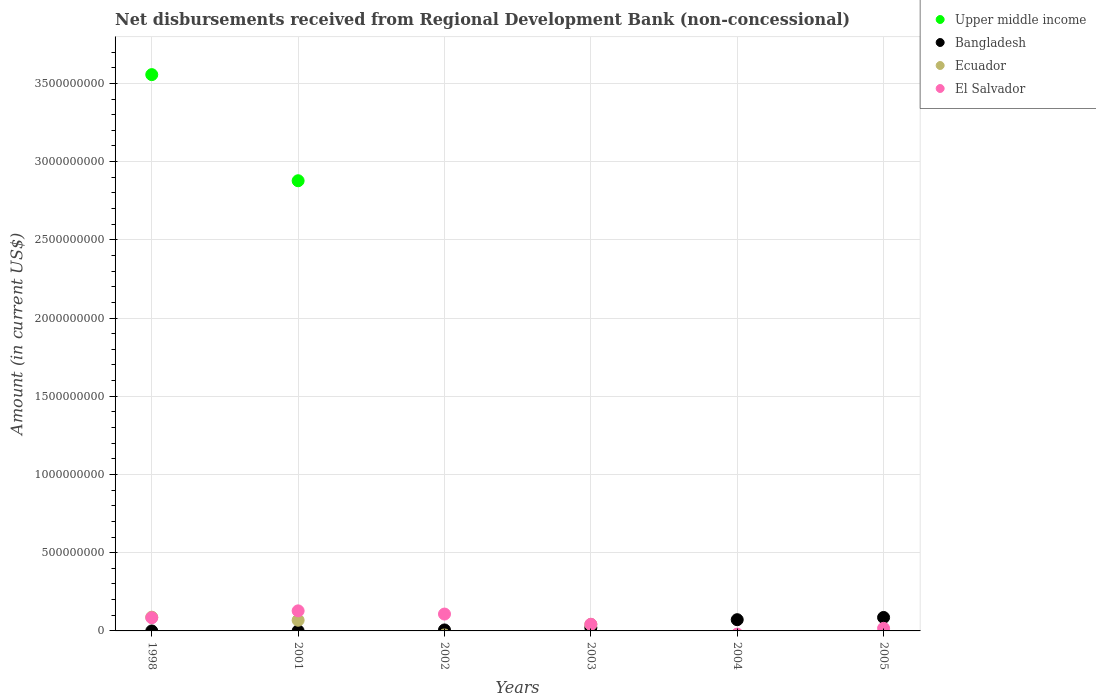What is the amount of disbursements received from Regional Development Bank in Upper middle income in 2001?
Your response must be concise. 2.88e+09. Across all years, what is the maximum amount of disbursements received from Regional Development Bank in El Salvador?
Provide a short and direct response. 1.28e+08. Across all years, what is the minimum amount of disbursements received from Regional Development Bank in El Salvador?
Make the answer very short. 0. In which year was the amount of disbursements received from Regional Development Bank in El Salvador maximum?
Provide a succinct answer. 2001. What is the total amount of disbursements received from Regional Development Bank in Ecuador in the graph?
Your response must be concise. 1.98e+08. What is the difference between the amount of disbursements received from Regional Development Bank in Bangladesh in 2002 and that in 2004?
Your answer should be compact. -6.55e+07. What is the difference between the amount of disbursements received from Regional Development Bank in Bangladesh in 2004 and the amount of disbursements received from Regional Development Bank in Ecuador in 2002?
Offer a terse response. 7.18e+07. What is the average amount of disbursements received from Regional Development Bank in Bangladesh per year?
Your answer should be very brief. 3.08e+07. In the year 2005, what is the difference between the amount of disbursements received from Regional Development Bank in Bangladesh and amount of disbursements received from Regional Development Bank in El Salvador?
Your response must be concise. 6.94e+07. What is the ratio of the amount of disbursements received from Regional Development Bank in El Salvador in 2003 to that in 2005?
Provide a succinct answer. 2.54. What is the difference between the highest and the second highest amount of disbursements received from Regional Development Bank in Bangladesh?
Make the answer very short. 1.43e+07. What is the difference between the highest and the lowest amount of disbursements received from Regional Development Bank in El Salvador?
Your answer should be compact. 1.28e+08. Does the amount of disbursements received from Regional Development Bank in Upper middle income monotonically increase over the years?
Offer a terse response. No. Is the amount of disbursements received from Regional Development Bank in El Salvador strictly less than the amount of disbursements received from Regional Development Bank in Bangladesh over the years?
Make the answer very short. No. How many years are there in the graph?
Keep it short and to the point. 6. What is the difference between two consecutive major ticks on the Y-axis?
Provide a short and direct response. 5.00e+08. Does the graph contain grids?
Provide a short and direct response. Yes. How are the legend labels stacked?
Your answer should be compact. Vertical. What is the title of the graph?
Offer a very short reply. Net disbursements received from Regional Development Bank (non-concessional). What is the label or title of the X-axis?
Offer a very short reply. Years. What is the label or title of the Y-axis?
Your answer should be compact. Amount (in current US$). What is the Amount (in current US$) in Upper middle income in 1998?
Your answer should be very brief. 3.56e+09. What is the Amount (in current US$) of Bangladesh in 1998?
Your answer should be compact. 0. What is the Amount (in current US$) of Ecuador in 1998?
Give a very brief answer. 8.79e+07. What is the Amount (in current US$) in El Salvador in 1998?
Offer a terse response. 8.43e+07. What is the Amount (in current US$) in Upper middle income in 2001?
Your answer should be compact. 2.88e+09. What is the Amount (in current US$) in Bangladesh in 2001?
Provide a succinct answer. 2.38e+05. What is the Amount (in current US$) of Ecuador in 2001?
Keep it short and to the point. 6.83e+07. What is the Amount (in current US$) in El Salvador in 2001?
Provide a short and direct response. 1.28e+08. What is the Amount (in current US$) in Upper middle income in 2002?
Provide a succinct answer. 0. What is the Amount (in current US$) of Bangladesh in 2002?
Give a very brief answer. 6.25e+06. What is the Amount (in current US$) of El Salvador in 2002?
Your response must be concise. 1.08e+08. What is the Amount (in current US$) in Bangladesh in 2003?
Offer a very short reply. 2.05e+07. What is the Amount (in current US$) of Ecuador in 2003?
Provide a short and direct response. 4.21e+07. What is the Amount (in current US$) in El Salvador in 2003?
Offer a very short reply. 4.24e+07. What is the Amount (in current US$) of Bangladesh in 2004?
Your answer should be very brief. 7.18e+07. What is the Amount (in current US$) of Ecuador in 2004?
Your answer should be very brief. 0. What is the Amount (in current US$) of El Salvador in 2004?
Make the answer very short. 0. What is the Amount (in current US$) of Bangladesh in 2005?
Offer a terse response. 8.61e+07. What is the Amount (in current US$) of El Salvador in 2005?
Ensure brevity in your answer.  1.67e+07. Across all years, what is the maximum Amount (in current US$) of Upper middle income?
Keep it short and to the point. 3.56e+09. Across all years, what is the maximum Amount (in current US$) of Bangladesh?
Your answer should be very brief. 8.61e+07. Across all years, what is the maximum Amount (in current US$) of Ecuador?
Keep it short and to the point. 8.79e+07. Across all years, what is the maximum Amount (in current US$) in El Salvador?
Your answer should be compact. 1.28e+08. Across all years, what is the minimum Amount (in current US$) of Upper middle income?
Make the answer very short. 0. Across all years, what is the minimum Amount (in current US$) in Bangladesh?
Keep it short and to the point. 0. Across all years, what is the minimum Amount (in current US$) of Ecuador?
Your answer should be very brief. 0. What is the total Amount (in current US$) of Upper middle income in the graph?
Your response must be concise. 6.43e+09. What is the total Amount (in current US$) in Bangladesh in the graph?
Provide a short and direct response. 1.85e+08. What is the total Amount (in current US$) in Ecuador in the graph?
Keep it short and to the point. 1.98e+08. What is the total Amount (in current US$) of El Salvador in the graph?
Offer a very short reply. 3.79e+08. What is the difference between the Amount (in current US$) of Upper middle income in 1998 and that in 2001?
Your response must be concise. 6.78e+08. What is the difference between the Amount (in current US$) of Ecuador in 1998 and that in 2001?
Provide a short and direct response. 1.96e+07. What is the difference between the Amount (in current US$) in El Salvador in 1998 and that in 2001?
Give a very brief answer. -4.39e+07. What is the difference between the Amount (in current US$) in El Salvador in 1998 and that in 2002?
Offer a terse response. -2.35e+07. What is the difference between the Amount (in current US$) in Ecuador in 1998 and that in 2003?
Your response must be concise. 4.58e+07. What is the difference between the Amount (in current US$) in El Salvador in 1998 and that in 2003?
Your answer should be very brief. 4.20e+07. What is the difference between the Amount (in current US$) in El Salvador in 1998 and that in 2005?
Offer a very short reply. 6.77e+07. What is the difference between the Amount (in current US$) in Bangladesh in 2001 and that in 2002?
Ensure brevity in your answer.  -6.01e+06. What is the difference between the Amount (in current US$) of El Salvador in 2001 and that in 2002?
Provide a succinct answer. 2.04e+07. What is the difference between the Amount (in current US$) of Bangladesh in 2001 and that in 2003?
Provide a succinct answer. -2.03e+07. What is the difference between the Amount (in current US$) of Ecuador in 2001 and that in 2003?
Your response must be concise. 2.61e+07. What is the difference between the Amount (in current US$) of El Salvador in 2001 and that in 2003?
Make the answer very short. 8.59e+07. What is the difference between the Amount (in current US$) in Bangladesh in 2001 and that in 2004?
Your answer should be very brief. -7.15e+07. What is the difference between the Amount (in current US$) in Bangladesh in 2001 and that in 2005?
Your answer should be compact. -8.58e+07. What is the difference between the Amount (in current US$) in El Salvador in 2001 and that in 2005?
Your answer should be very brief. 1.12e+08. What is the difference between the Amount (in current US$) of Bangladesh in 2002 and that in 2003?
Keep it short and to the point. -1.43e+07. What is the difference between the Amount (in current US$) in El Salvador in 2002 and that in 2003?
Give a very brief answer. 6.55e+07. What is the difference between the Amount (in current US$) in Bangladesh in 2002 and that in 2004?
Ensure brevity in your answer.  -6.55e+07. What is the difference between the Amount (in current US$) in Bangladesh in 2002 and that in 2005?
Give a very brief answer. -7.98e+07. What is the difference between the Amount (in current US$) in El Salvador in 2002 and that in 2005?
Offer a very short reply. 9.12e+07. What is the difference between the Amount (in current US$) of Bangladesh in 2003 and that in 2004?
Keep it short and to the point. -5.13e+07. What is the difference between the Amount (in current US$) of Bangladesh in 2003 and that in 2005?
Keep it short and to the point. -6.56e+07. What is the difference between the Amount (in current US$) in El Salvador in 2003 and that in 2005?
Ensure brevity in your answer.  2.57e+07. What is the difference between the Amount (in current US$) in Bangladesh in 2004 and that in 2005?
Ensure brevity in your answer.  -1.43e+07. What is the difference between the Amount (in current US$) in Upper middle income in 1998 and the Amount (in current US$) in Bangladesh in 2001?
Give a very brief answer. 3.56e+09. What is the difference between the Amount (in current US$) in Upper middle income in 1998 and the Amount (in current US$) in Ecuador in 2001?
Your answer should be compact. 3.49e+09. What is the difference between the Amount (in current US$) in Upper middle income in 1998 and the Amount (in current US$) in El Salvador in 2001?
Provide a short and direct response. 3.43e+09. What is the difference between the Amount (in current US$) of Ecuador in 1998 and the Amount (in current US$) of El Salvador in 2001?
Your answer should be compact. -4.03e+07. What is the difference between the Amount (in current US$) of Upper middle income in 1998 and the Amount (in current US$) of Bangladesh in 2002?
Offer a very short reply. 3.55e+09. What is the difference between the Amount (in current US$) of Upper middle income in 1998 and the Amount (in current US$) of El Salvador in 2002?
Offer a very short reply. 3.45e+09. What is the difference between the Amount (in current US$) in Ecuador in 1998 and the Amount (in current US$) in El Salvador in 2002?
Provide a short and direct response. -2.00e+07. What is the difference between the Amount (in current US$) in Upper middle income in 1998 and the Amount (in current US$) in Bangladesh in 2003?
Your answer should be compact. 3.54e+09. What is the difference between the Amount (in current US$) in Upper middle income in 1998 and the Amount (in current US$) in Ecuador in 2003?
Your answer should be compact. 3.51e+09. What is the difference between the Amount (in current US$) in Upper middle income in 1998 and the Amount (in current US$) in El Salvador in 2003?
Keep it short and to the point. 3.51e+09. What is the difference between the Amount (in current US$) in Ecuador in 1998 and the Amount (in current US$) in El Salvador in 2003?
Your answer should be compact. 4.55e+07. What is the difference between the Amount (in current US$) of Upper middle income in 1998 and the Amount (in current US$) of Bangladesh in 2004?
Your response must be concise. 3.48e+09. What is the difference between the Amount (in current US$) of Upper middle income in 1998 and the Amount (in current US$) of Bangladesh in 2005?
Ensure brevity in your answer.  3.47e+09. What is the difference between the Amount (in current US$) of Upper middle income in 1998 and the Amount (in current US$) of El Salvador in 2005?
Your answer should be very brief. 3.54e+09. What is the difference between the Amount (in current US$) in Ecuador in 1998 and the Amount (in current US$) in El Salvador in 2005?
Your response must be concise. 7.12e+07. What is the difference between the Amount (in current US$) of Upper middle income in 2001 and the Amount (in current US$) of Bangladesh in 2002?
Give a very brief answer. 2.87e+09. What is the difference between the Amount (in current US$) in Upper middle income in 2001 and the Amount (in current US$) in El Salvador in 2002?
Give a very brief answer. 2.77e+09. What is the difference between the Amount (in current US$) of Bangladesh in 2001 and the Amount (in current US$) of El Salvador in 2002?
Your answer should be compact. -1.08e+08. What is the difference between the Amount (in current US$) in Ecuador in 2001 and the Amount (in current US$) in El Salvador in 2002?
Offer a very short reply. -3.96e+07. What is the difference between the Amount (in current US$) in Upper middle income in 2001 and the Amount (in current US$) in Bangladesh in 2003?
Provide a succinct answer. 2.86e+09. What is the difference between the Amount (in current US$) in Upper middle income in 2001 and the Amount (in current US$) in Ecuador in 2003?
Provide a short and direct response. 2.84e+09. What is the difference between the Amount (in current US$) of Upper middle income in 2001 and the Amount (in current US$) of El Salvador in 2003?
Make the answer very short. 2.84e+09. What is the difference between the Amount (in current US$) in Bangladesh in 2001 and the Amount (in current US$) in Ecuador in 2003?
Your response must be concise. -4.19e+07. What is the difference between the Amount (in current US$) of Bangladesh in 2001 and the Amount (in current US$) of El Salvador in 2003?
Your answer should be very brief. -4.21e+07. What is the difference between the Amount (in current US$) in Ecuador in 2001 and the Amount (in current US$) in El Salvador in 2003?
Provide a succinct answer. 2.59e+07. What is the difference between the Amount (in current US$) in Upper middle income in 2001 and the Amount (in current US$) in Bangladesh in 2004?
Your response must be concise. 2.81e+09. What is the difference between the Amount (in current US$) in Upper middle income in 2001 and the Amount (in current US$) in Bangladesh in 2005?
Provide a short and direct response. 2.79e+09. What is the difference between the Amount (in current US$) in Upper middle income in 2001 and the Amount (in current US$) in El Salvador in 2005?
Offer a terse response. 2.86e+09. What is the difference between the Amount (in current US$) in Bangladesh in 2001 and the Amount (in current US$) in El Salvador in 2005?
Offer a terse response. -1.64e+07. What is the difference between the Amount (in current US$) of Ecuador in 2001 and the Amount (in current US$) of El Salvador in 2005?
Offer a terse response. 5.16e+07. What is the difference between the Amount (in current US$) in Bangladesh in 2002 and the Amount (in current US$) in Ecuador in 2003?
Offer a very short reply. -3.59e+07. What is the difference between the Amount (in current US$) in Bangladesh in 2002 and the Amount (in current US$) in El Salvador in 2003?
Ensure brevity in your answer.  -3.61e+07. What is the difference between the Amount (in current US$) of Bangladesh in 2002 and the Amount (in current US$) of El Salvador in 2005?
Provide a short and direct response. -1.04e+07. What is the difference between the Amount (in current US$) in Bangladesh in 2003 and the Amount (in current US$) in El Salvador in 2005?
Give a very brief answer. 3.84e+06. What is the difference between the Amount (in current US$) in Ecuador in 2003 and the Amount (in current US$) in El Salvador in 2005?
Give a very brief answer. 2.55e+07. What is the difference between the Amount (in current US$) of Bangladesh in 2004 and the Amount (in current US$) of El Salvador in 2005?
Offer a terse response. 5.51e+07. What is the average Amount (in current US$) in Upper middle income per year?
Your response must be concise. 1.07e+09. What is the average Amount (in current US$) of Bangladesh per year?
Provide a short and direct response. 3.08e+07. What is the average Amount (in current US$) in Ecuador per year?
Make the answer very short. 3.31e+07. What is the average Amount (in current US$) of El Salvador per year?
Keep it short and to the point. 6.32e+07. In the year 1998, what is the difference between the Amount (in current US$) of Upper middle income and Amount (in current US$) of Ecuador?
Ensure brevity in your answer.  3.47e+09. In the year 1998, what is the difference between the Amount (in current US$) of Upper middle income and Amount (in current US$) of El Salvador?
Make the answer very short. 3.47e+09. In the year 1998, what is the difference between the Amount (in current US$) in Ecuador and Amount (in current US$) in El Salvador?
Your response must be concise. 3.55e+06. In the year 2001, what is the difference between the Amount (in current US$) in Upper middle income and Amount (in current US$) in Bangladesh?
Offer a very short reply. 2.88e+09. In the year 2001, what is the difference between the Amount (in current US$) of Upper middle income and Amount (in current US$) of Ecuador?
Offer a very short reply. 2.81e+09. In the year 2001, what is the difference between the Amount (in current US$) of Upper middle income and Amount (in current US$) of El Salvador?
Ensure brevity in your answer.  2.75e+09. In the year 2001, what is the difference between the Amount (in current US$) in Bangladesh and Amount (in current US$) in Ecuador?
Your answer should be very brief. -6.81e+07. In the year 2001, what is the difference between the Amount (in current US$) in Bangladesh and Amount (in current US$) in El Salvador?
Your answer should be compact. -1.28e+08. In the year 2001, what is the difference between the Amount (in current US$) in Ecuador and Amount (in current US$) in El Salvador?
Make the answer very short. -6.00e+07. In the year 2002, what is the difference between the Amount (in current US$) of Bangladesh and Amount (in current US$) of El Salvador?
Provide a succinct answer. -1.02e+08. In the year 2003, what is the difference between the Amount (in current US$) of Bangladesh and Amount (in current US$) of Ecuador?
Keep it short and to the point. -2.16e+07. In the year 2003, what is the difference between the Amount (in current US$) of Bangladesh and Amount (in current US$) of El Salvador?
Your answer should be compact. -2.19e+07. In the year 2003, what is the difference between the Amount (in current US$) of Ecuador and Amount (in current US$) of El Salvador?
Provide a short and direct response. -2.26e+05. In the year 2005, what is the difference between the Amount (in current US$) of Bangladesh and Amount (in current US$) of El Salvador?
Offer a terse response. 6.94e+07. What is the ratio of the Amount (in current US$) in Upper middle income in 1998 to that in 2001?
Provide a succinct answer. 1.24. What is the ratio of the Amount (in current US$) in Ecuador in 1998 to that in 2001?
Provide a succinct answer. 1.29. What is the ratio of the Amount (in current US$) in El Salvador in 1998 to that in 2001?
Offer a very short reply. 0.66. What is the ratio of the Amount (in current US$) of El Salvador in 1998 to that in 2002?
Ensure brevity in your answer.  0.78. What is the ratio of the Amount (in current US$) of Ecuador in 1998 to that in 2003?
Give a very brief answer. 2.09. What is the ratio of the Amount (in current US$) of El Salvador in 1998 to that in 2003?
Make the answer very short. 1.99. What is the ratio of the Amount (in current US$) in El Salvador in 1998 to that in 2005?
Keep it short and to the point. 5.06. What is the ratio of the Amount (in current US$) of Bangladesh in 2001 to that in 2002?
Ensure brevity in your answer.  0.04. What is the ratio of the Amount (in current US$) of El Salvador in 2001 to that in 2002?
Your response must be concise. 1.19. What is the ratio of the Amount (in current US$) in Bangladesh in 2001 to that in 2003?
Keep it short and to the point. 0.01. What is the ratio of the Amount (in current US$) of Ecuador in 2001 to that in 2003?
Make the answer very short. 1.62. What is the ratio of the Amount (in current US$) of El Salvador in 2001 to that in 2003?
Your answer should be very brief. 3.03. What is the ratio of the Amount (in current US$) in Bangladesh in 2001 to that in 2004?
Keep it short and to the point. 0. What is the ratio of the Amount (in current US$) in Bangladesh in 2001 to that in 2005?
Offer a very short reply. 0. What is the ratio of the Amount (in current US$) of El Salvador in 2001 to that in 2005?
Offer a very short reply. 7.7. What is the ratio of the Amount (in current US$) of Bangladesh in 2002 to that in 2003?
Give a very brief answer. 0.3. What is the ratio of the Amount (in current US$) in El Salvador in 2002 to that in 2003?
Provide a succinct answer. 2.55. What is the ratio of the Amount (in current US$) in Bangladesh in 2002 to that in 2004?
Offer a very short reply. 0.09. What is the ratio of the Amount (in current US$) in Bangladesh in 2002 to that in 2005?
Give a very brief answer. 0.07. What is the ratio of the Amount (in current US$) in El Salvador in 2002 to that in 2005?
Give a very brief answer. 6.47. What is the ratio of the Amount (in current US$) of Bangladesh in 2003 to that in 2004?
Your response must be concise. 0.29. What is the ratio of the Amount (in current US$) of Bangladesh in 2003 to that in 2005?
Offer a terse response. 0.24. What is the ratio of the Amount (in current US$) in El Salvador in 2003 to that in 2005?
Your answer should be compact. 2.54. What is the ratio of the Amount (in current US$) of Bangladesh in 2004 to that in 2005?
Provide a short and direct response. 0.83. What is the difference between the highest and the second highest Amount (in current US$) of Bangladesh?
Your answer should be compact. 1.43e+07. What is the difference between the highest and the second highest Amount (in current US$) of Ecuador?
Your answer should be compact. 1.96e+07. What is the difference between the highest and the second highest Amount (in current US$) in El Salvador?
Your answer should be compact. 2.04e+07. What is the difference between the highest and the lowest Amount (in current US$) of Upper middle income?
Ensure brevity in your answer.  3.56e+09. What is the difference between the highest and the lowest Amount (in current US$) of Bangladesh?
Provide a succinct answer. 8.61e+07. What is the difference between the highest and the lowest Amount (in current US$) in Ecuador?
Provide a succinct answer. 8.79e+07. What is the difference between the highest and the lowest Amount (in current US$) of El Salvador?
Provide a short and direct response. 1.28e+08. 